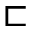Convert formula to latex. <formula><loc_0><loc_0><loc_500><loc_500>\sqsubset</formula> 